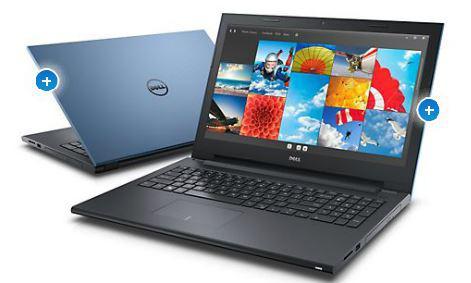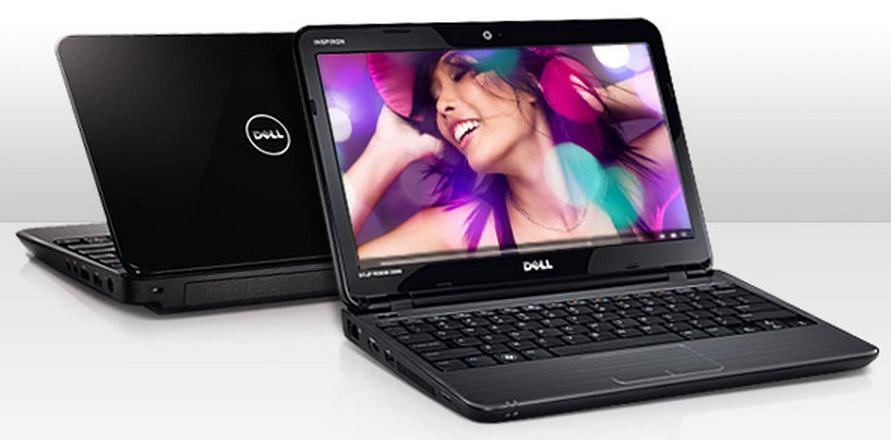The first image is the image on the left, the second image is the image on the right. For the images displayed, is the sentence "One of the images contains exactly three computers" factually correct? Answer yes or no. No. The first image is the image on the left, the second image is the image on the right. Analyze the images presented: Is the assertion "The right and left images contain the same number of laptops." valid? Answer yes or no. Yes. 